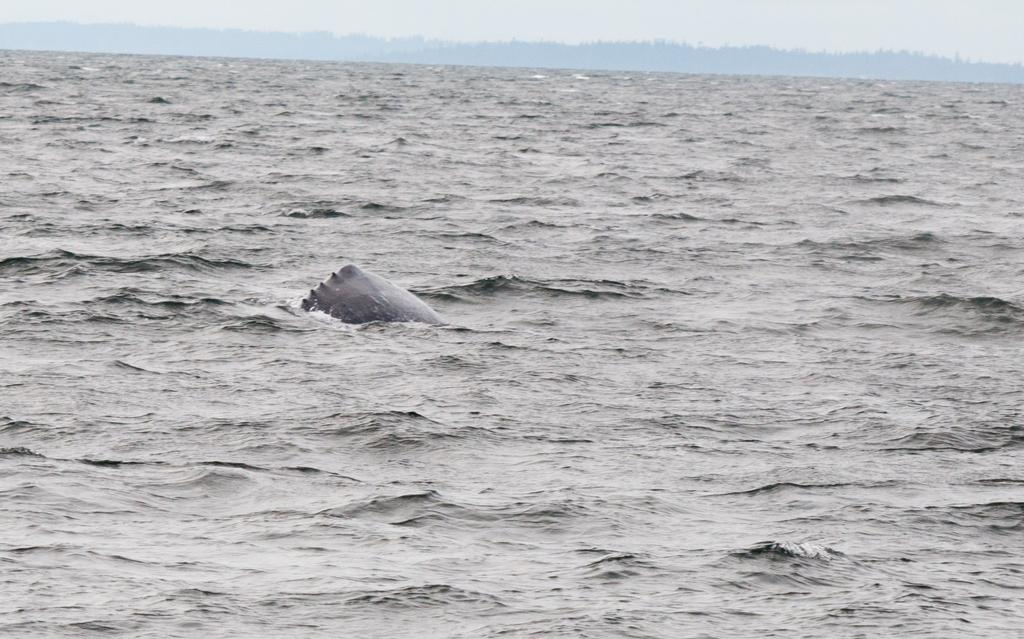What is located in the river in the image? There is an object in the river in the image. What can be seen in the background of the image? There is a sky visible in the background of the image. How does the wall increase in size in the image? There is no wall present in the image, so it cannot increase in size. 